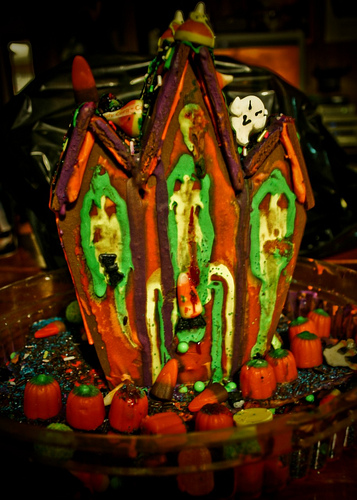<image>
Can you confirm if the ghost is behind the pumpkin? No. The ghost is not behind the pumpkin. From this viewpoint, the ghost appears to be positioned elsewhere in the scene. 